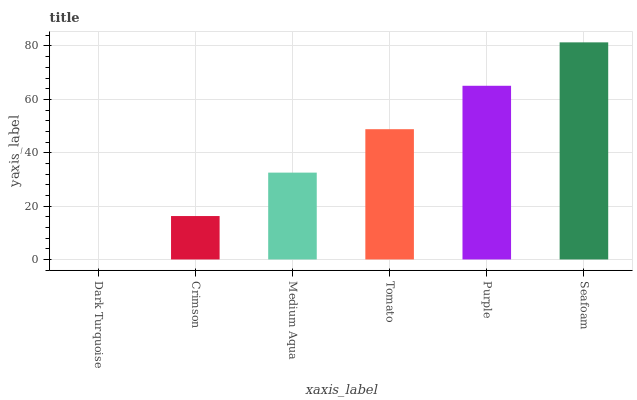Is Dark Turquoise the minimum?
Answer yes or no. Yes. Is Seafoam the maximum?
Answer yes or no. Yes. Is Crimson the minimum?
Answer yes or no. No. Is Crimson the maximum?
Answer yes or no. No. Is Crimson greater than Dark Turquoise?
Answer yes or no. Yes. Is Dark Turquoise less than Crimson?
Answer yes or no. Yes. Is Dark Turquoise greater than Crimson?
Answer yes or no. No. Is Crimson less than Dark Turquoise?
Answer yes or no. No. Is Tomato the high median?
Answer yes or no. Yes. Is Medium Aqua the low median?
Answer yes or no. Yes. Is Purple the high median?
Answer yes or no. No. Is Purple the low median?
Answer yes or no. No. 